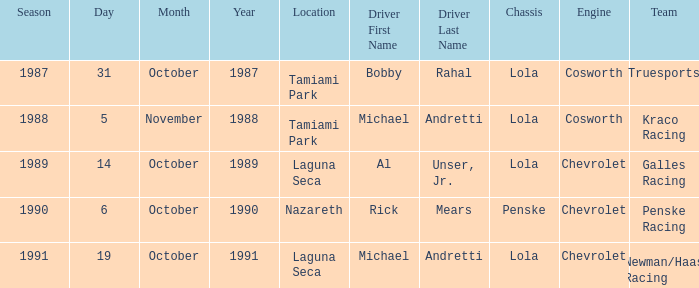When was the race at nazareth held? October 6. Would you be able to parse every entry in this table? {'header': ['Season', 'Day', 'Month', 'Year', 'Location', 'Driver First Name', 'Driver Last Name', 'Chassis', 'Engine', 'Team'], 'rows': [['1987', '31', 'October', '1987', 'Tamiami Park', 'Bobby', 'Rahal', 'Lola', 'Cosworth', 'Truesports'], ['1988', '5', 'November', '1988', 'Tamiami Park', 'Michael', 'Andretti', 'Lola', 'Cosworth', 'Kraco Racing'], ['1989', '14', 'October', '1989', 'Laguna Seca', 'Al', 'Unser, Jr.', 'Lola', 'Chevrolet', 'Galles Racing'], ['1990', '6', 'October', '1990', 'Nazareth', 'Rick', 'Mears', 'Penske', 'Chevrolet', 'Penske Racing'], ['1991', '19', 'October', '1991', 'Laguna Seca', 'Michael', 'Andretti', 'Lola', 'Chevrolet', 'Newman/Haas Racing']]} 